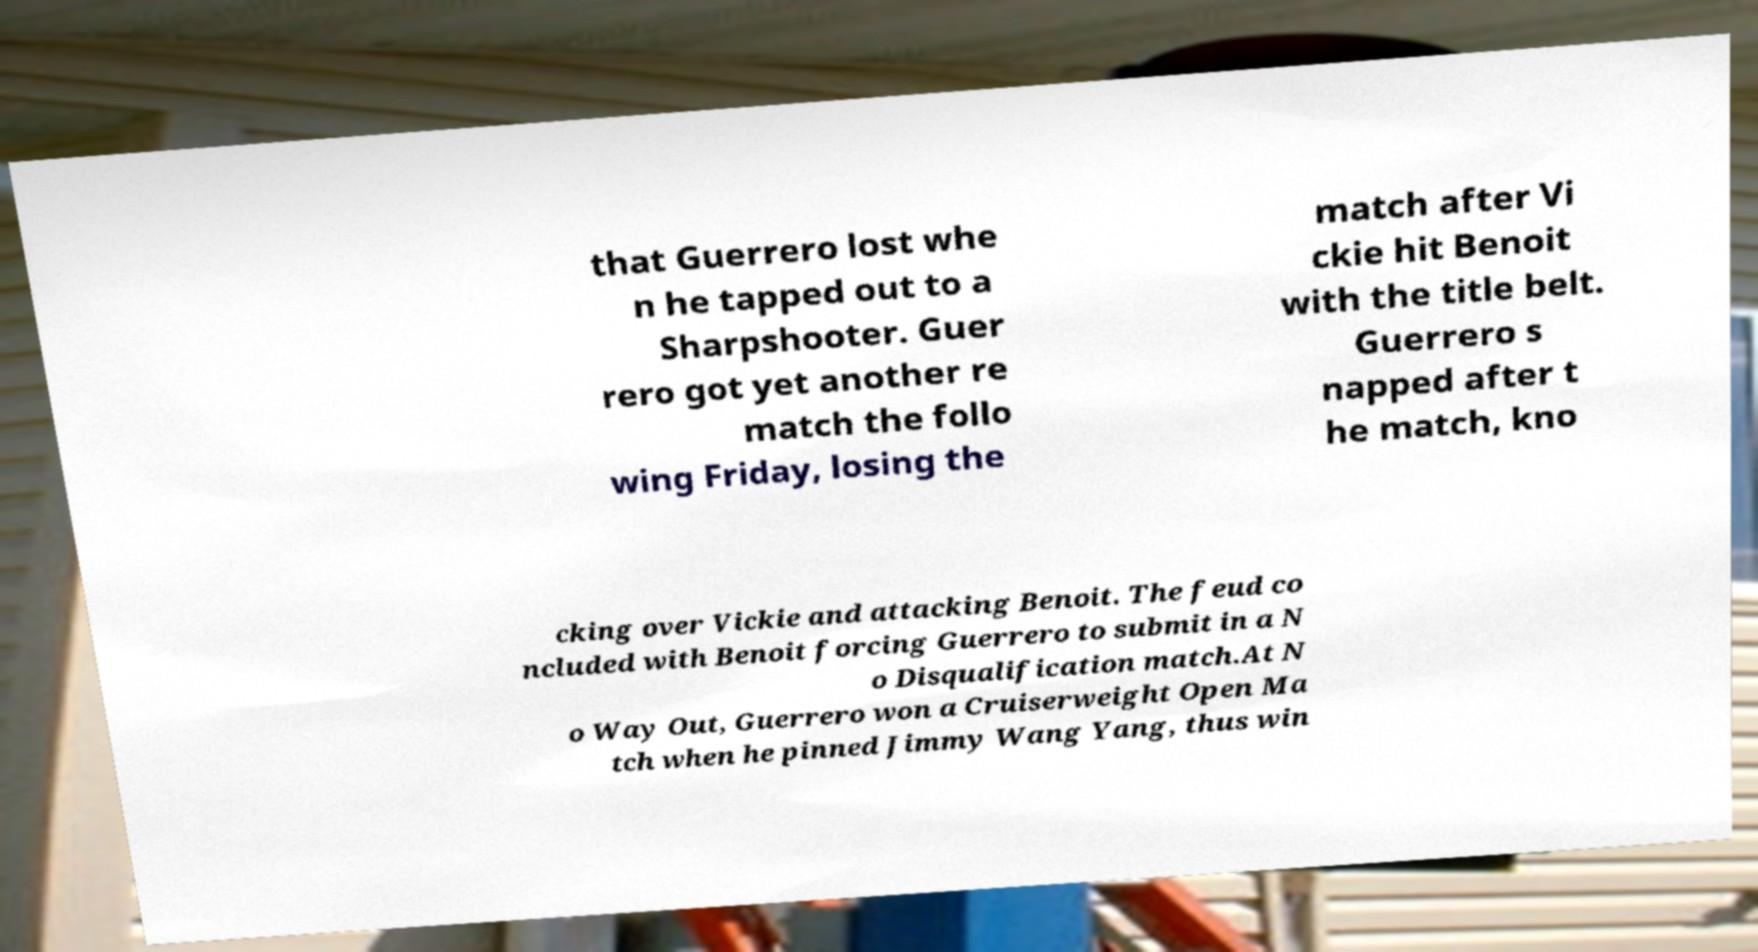Please identify and transcribe the text found in this image. that Guerrero lost whe n he tapped out to a Sharpshooter. Guer rero got yet another re match the follo wing Friday, losing the match after Vi ckie hit Benoit with the title belt. Guerrero s napped after t he match, kno cking over Vickie and attacking Benoit. The feud co ncluded with Benoit forcing Guerrero to submit in a N o Disqualification match.At N o Way Out, Guerrero won a Cruiserweight Open Ma tch when he pinned Jimmy Wang Yang, thus win 